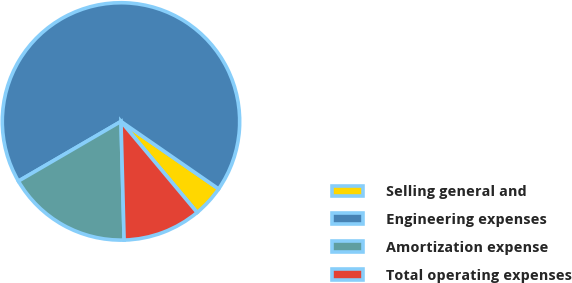Convert chart to OTSL. <chart><loc_0><loc_0><loc_500><loc_500><pie_chart><fcel>Selling general and<fcel>Engineering expenses<fcel>Amortization expense<fcel>Total operating expenses<nl><fcel>4.29%<fcel>68.01%<fcel>17.03%<fcel>10.66%<nl></chart> 